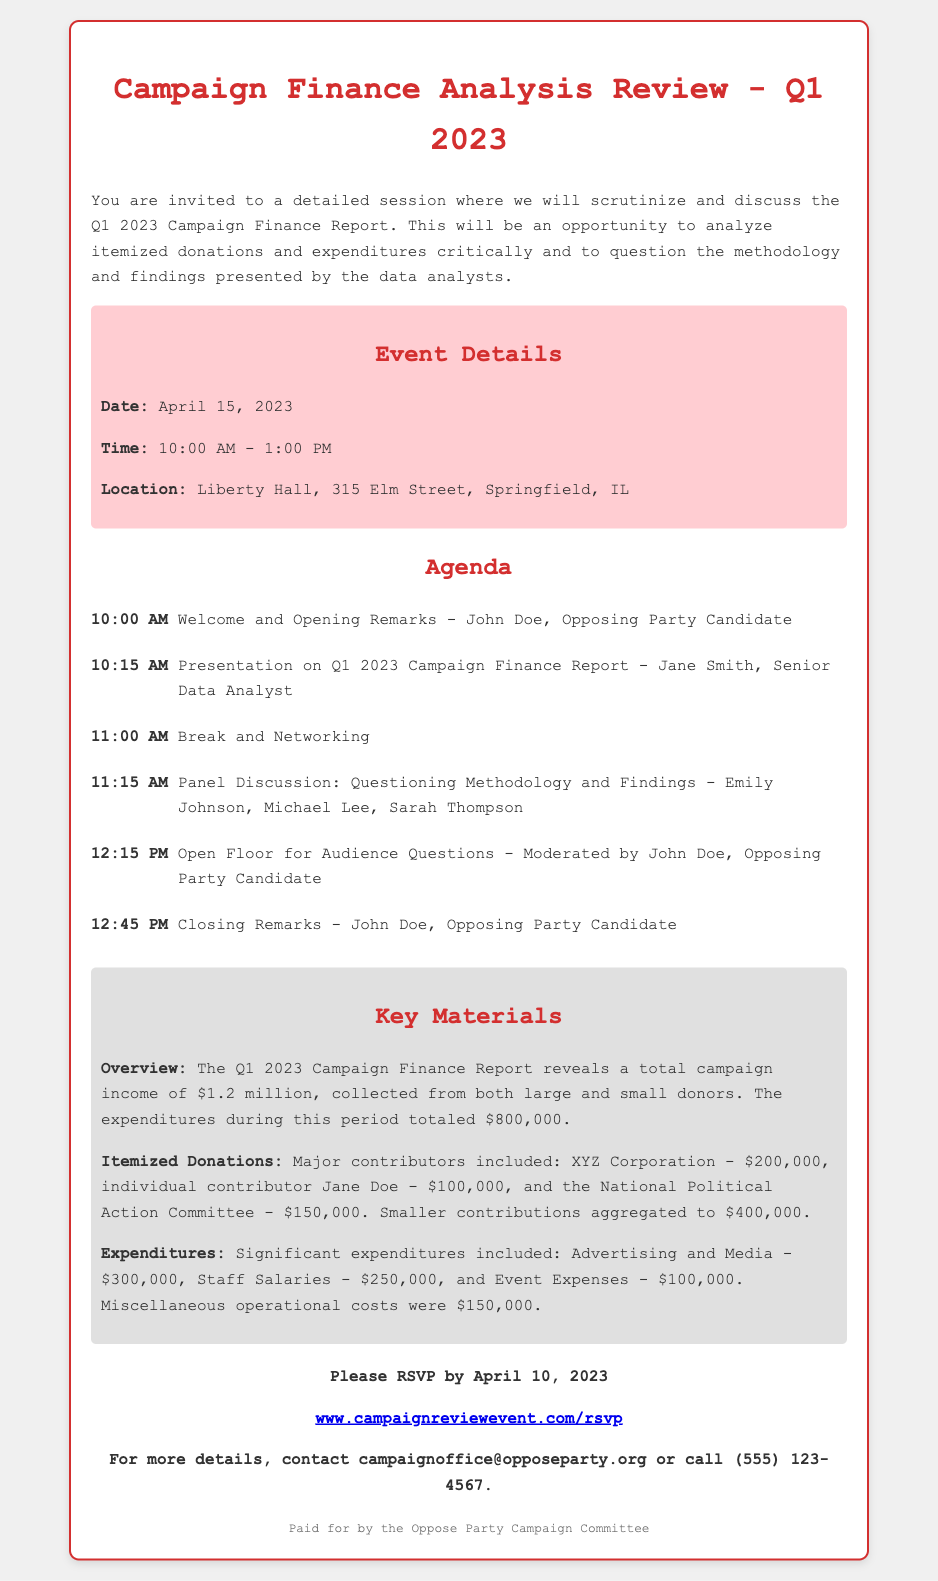What is the total campaign income? The total campaign income is stated in the overview as $1.2 million.
Answer: $1.2 million What date is the event scheduled for? The event is scheduled for April 15, 2023, as mentioned in the event details.
Answer: April 15, 2023 Who presented the Q1 2023 Campaign Finance Report? The presentation on the Q1 2023 Campaign Finance Report was given by Jane Smith, as noted in the agenda.
Answer: Jane Smith What was the total expenditure during this period? The total expenditures during this period totalled $800,000 according to the overview.
Answer: $800,000 How much did XYZ Corporation contribute? XYZ Corporation contributed $200,000, as listed under itemized donations.
Answer: $200,000 What location will the event take place? The event will take place at Liberty Hall, as provided in the event details.
Answer: Liberty Hall What was the expenditure on Advertising and Media? The expenditure on Advertising and Media was $300,000, as detailed under expenditures.
Answer: $300,000 Which item is mentioned as a significant expenditure? Staff Salaries is mentioned as a significant expenditure, highlighted in the expenditures section.
Answer: Staff Salaries What is the RSVP deadline? The RSVP deadline is April 10, 2023, as indicated in the call to action section.
Answer: April 10, 2023 